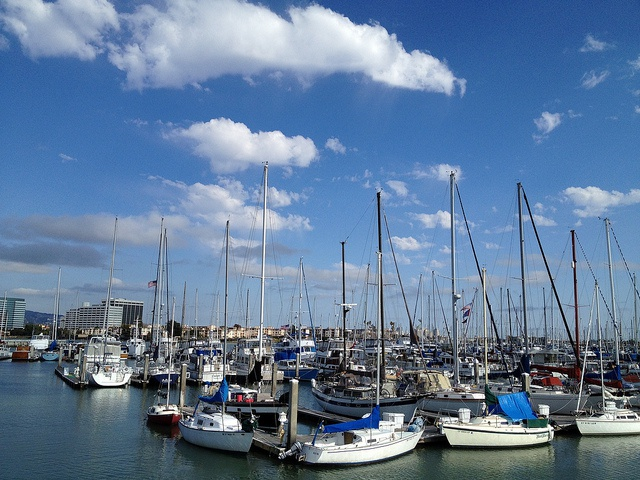Describe the objects in this image and their specific colors. I can see boat in gray, white, darkgray, and black tones, boat in gray, black, lightgray, and darkgray tones, boat in gray, black, blue, and lightgray tones, boat in gray, beige, darkgray, and black tones, and boat in gray, black, blue, and navy tones in this image. 